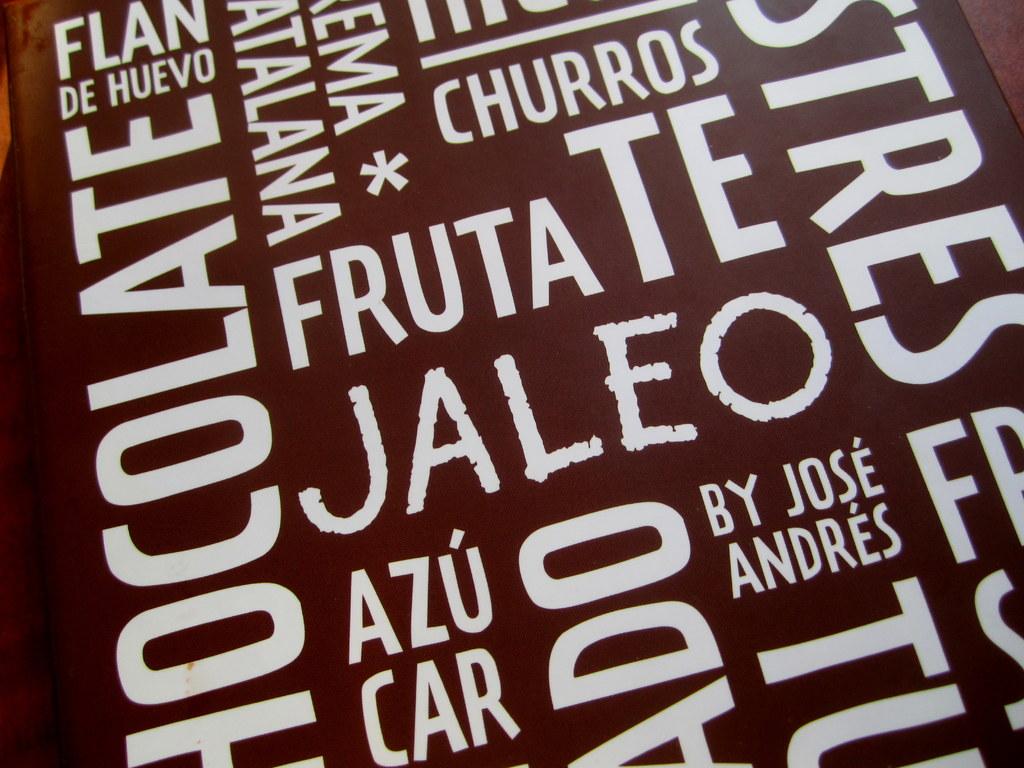Who makes the food?
Ensure brevity in your answer.  Jose andres. What kinds of food are there?
Provide a succinct answer. Mexican. 